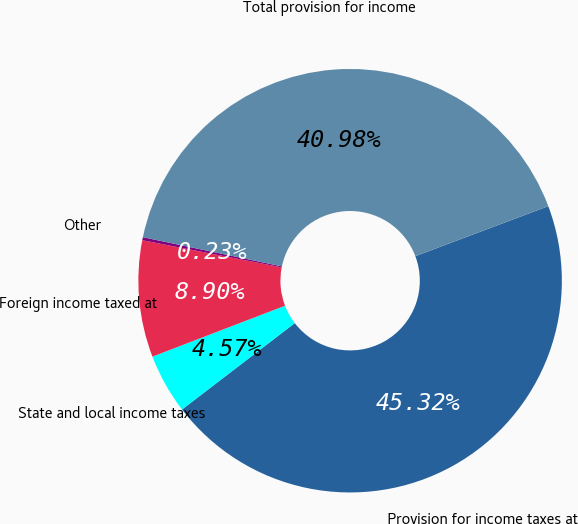Convert chart to OTSL. <chart><loc_0><loc_0><loc_500><loc_500><pie_chart><fcel>Provision for income taxes at<fcel>State and local income taxes<fcel>Foreign income taxed at<fcel>Other<fcel>Total provision for income<nl><fcel>45.32%<fcel>4.57%<fcel>8.9%<fcel>0.23%<fcel>40.98%<nl></chart> 